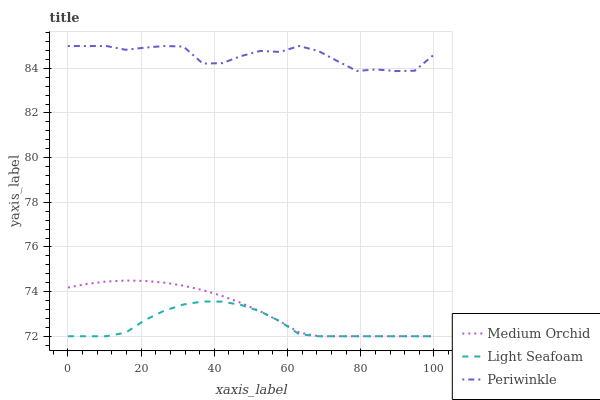Does Light Seafoam have the minimum area under the curve?
Answer yes or no. Yes. Does Periwinkle have the maximum area under the curve?
Answer yes or no. Yes. Does Periwinkle have the minimum area under the curve?
Answer yes or no. No. Does Light Seafoam have the maximum area under the curve?
Answer yes or no. No. Is Medium Orchid the smoothest?
Answer yes or no. Yes. Is Periwinkle the roughest?
Answer yes or no. Yes. Is Light Seafoam the smoothest?
Answer yes or no. No. Is Light Seafoam the roughest?
Answer yes or no. No. Does Medium Orchid have the lowest value?
Answer yes or no. Yes. Does Periwinkle have the lowest value?
Answer yes or no. No. Does Periwinkle have the highest value?
Answer yes or no. Yes. Does Light Seafoam have the highest value?
Answer yes or no. No. Is Medium Orchid less than Periwinkle?
Answer yes or no. Yes. Is Periwinkle greater than Medium Orchid?
Answer yes or no. Yes. Does Medium Orchid intersect Light Seafoam?
Answer yes or no. Yes. Is Medium Orchid less than Light Seafoam?
Answer yes or no. No. Is Medium Orchid greater than Light Seafoam?
Answer yes or no. No. Does Medium Orchid intersect Periwinkle?
Answer yes or no. No. 